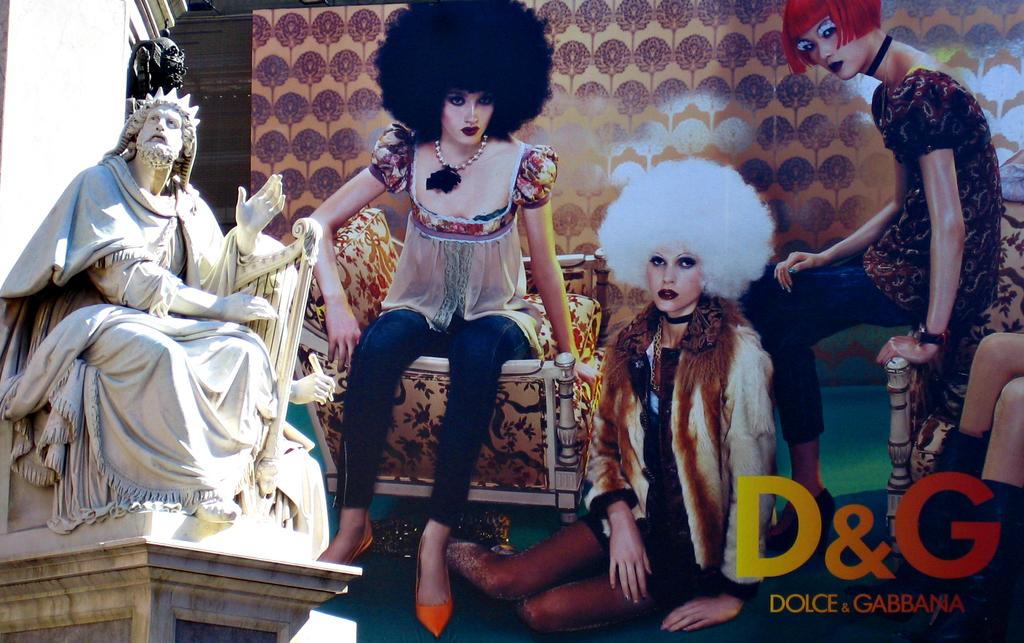What is located on the left side of the image? There is a sculpture on the left side of the image. What can be seen in the middle of the image? There are cartoon images of persons and sofa chairs in the middle of the image. What is written or depicted in the middle of the image? Text is present in the middle of the image. What can be seen in the background of the image? The background of the image includes a design wall. How many dogs are present in the image? There are no dogs present in the image. What type of bubble can be seen in the image? There is no bubble present in the image. 